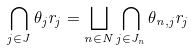Convert formula to latex. <formula><loc_0><loc_0><loc_500><loc_500>\bigcap _ { j \in J } \theta _ { j } r _ { j } = \bigsqcup _ { n \in N } \bigcap _ { j \in J _ { n } } \theta _ { n , j } r _ { j }</formula> 